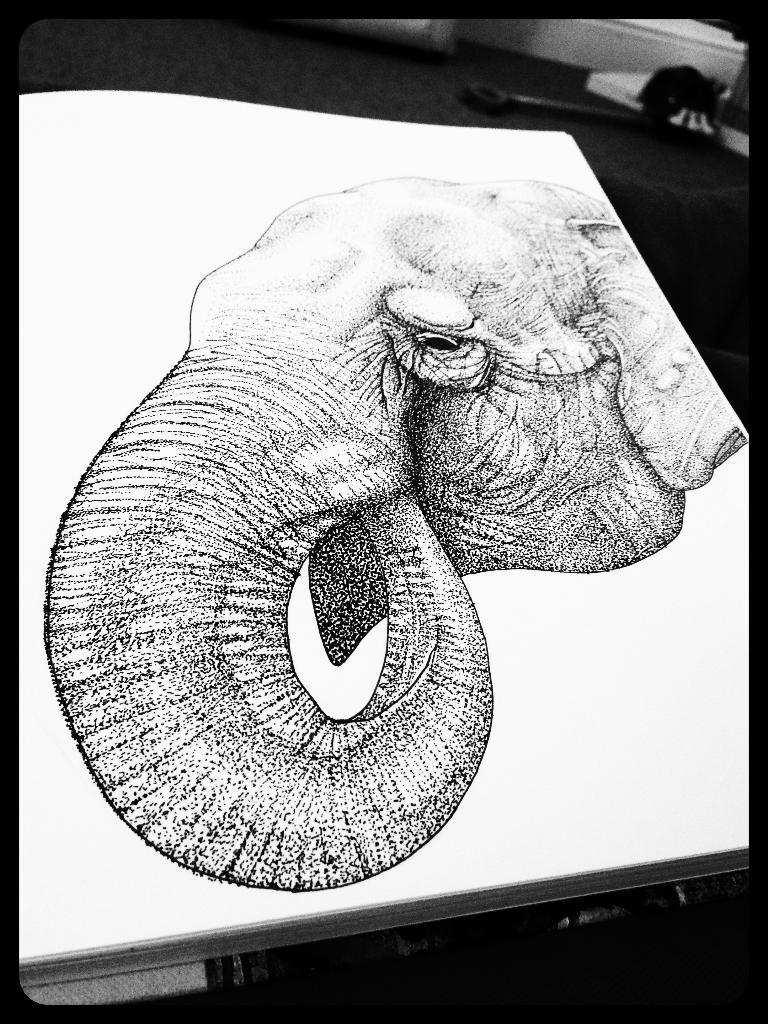What is the main subject in the center of the image? There is a board in the center of the image. What is depicted on the board? There is a drawing of an elephant on the board. Can you describe the background of the image? There are objects visible in the background of the image. Where is the fireman standing in the image? There is no fireman present in the image. Is there any smoke visible in the image? There is no smoke visible in the image. 